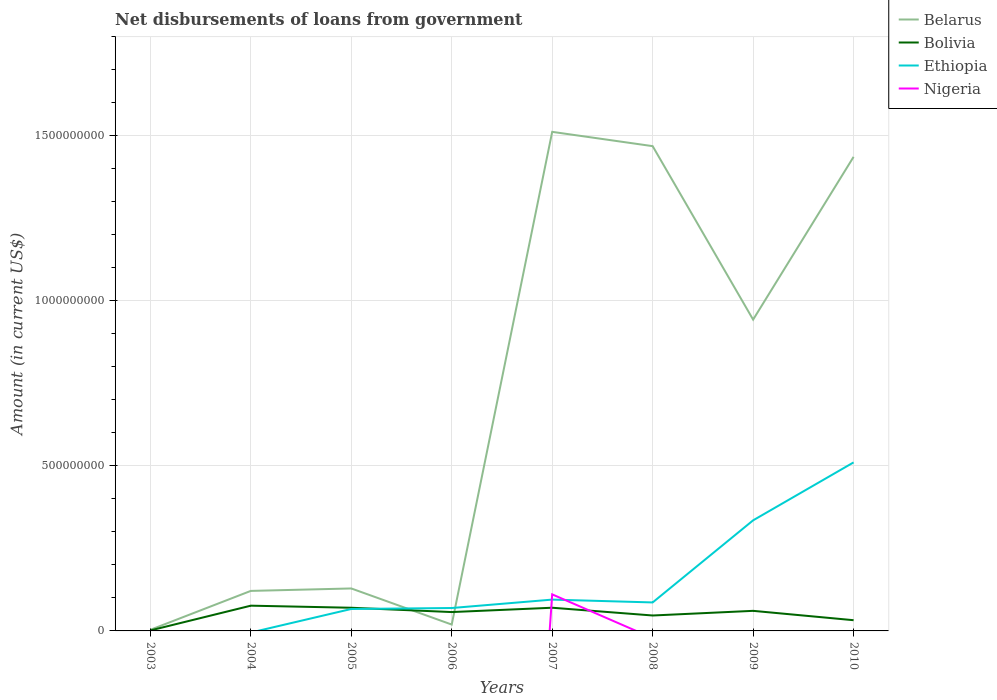Is the number of lines equal to the number of legend labels?
Provide a short and direct response. No. Across all years, what is the maximum amount of loan disbursed from government in Belarus?
Offer a terse response. 3.37e+06. What is the total amount of loan disbursed from government in Bolivia in the graph?
Your answer should be very brief. -1.31e+07. What is the difference between the highest and the second highest amount of loan disbursed from government in Nigeria?
Make the answer very short. 1.11e+08. Is the amount of loan disbursed from government in Belarus strictly greater than the amount of loan disbursed from government in Bolivia over the years?
Keep it short and to the point. No. How many lines are there?
Your response must be concise. 4. How many years are there in the graph?
Ensure brevity in your answer.  8. What is the difference between two consecutive major ticks on the Y-axis?
Your response must be concise. 5.00e+08. Are the values on the major ticks of Y-axis written in scientific E-notation?
Ensure brevity in your answer.  No. Does the graph contain any zero values?
Offer a very short reply. Yes. Does the graph contain grids?
Ensure brevity in your answer.  Yes. How many legend labels are there?
Your response must be concise. 4. How are the legend labels stacked?
Your answer should be compact. Vertical. What is the title of the graph?
Your answer should be very brief. Net disbursements of loans from government. What is the Amount (in current US$) in Belarus in 2003?
Offer a very short reply. 3.37e+06. What is the Amount (in current US$) in Bolivia in 2003?
Offer a terse response. 1.46e+06. What is the Amount (in current US$) in Belarus in 2004?
Your answer should be very brief. 1.21e+08. What is the Amount (in current US$) in Bolivia in 2004?
Make the answer very short. 7.65e+07. What is the Amount (in current US$) in Belarus in 2005?
Provide a succinct answer. 1.29e+08. What is the Amount (in current US$) in Bolivia in 2005?
Give a very brief answer. 7.02e+07. What is the Amount (in current US$) of Ethiopia in 2005?
Give a very brief answer. 6.65e+07. What is the Amount (in current US$) of Nigeria in 2005?
Offer a terse response. 0. What is the Amount (in current US$) in Belarus in 2006?
Ensure brevity in your answer.  1.93e+07. What is the Amount (in current US$) in Bolivia in 2006?
Give a very brief answer. 5.72e+07. What is the Amount (in current US$) in Ethiopia in 2006?
Provide a short and direct response. 6.94e+07. What is the Amount (in current US$) in Nigeria in 2006?
Offer a terse response. 0. What is the Amount (in current US$) of Belarus in 2007?
Keep it short and to the point. 1.51e+09. What is the Amount (in current US$) of Bolivia in 2007?
Keep it short and to the point. 7.03e+07. What is the Amount (in current US$) of Ethiopia in 2007?
Your answer should be very brief. 9.49e+07. What is the Amount (in current US$) in Nigeria in 2007?
Provide a succinct answer. 1.11e+08. What is the Amount (in current US$) in Belarus in 2008?
Keep it short and to the point. 1.47e+09. What is the Amount (in current US$) in Bolivia in 2008?
Provide a succinct answer. 4.68e+07. What is the Amount (in current US$) in Ethiopia in 2008?
Ensure brevity in your answer.  8.63e+07. What is the Amount (in current US$) of Belarus in 2009?
Offer a very short reply. 9.43e+08. What is the Amount (in current US$) of Bolivia in 2009?
Ensure brevity in your answer.  6.08e+07. What is the Amount (in current US$) in Ethiopia in 2009?
Your answer should be very brief. 3.35e+08. What is the Amount (in current US$) of Belarus in 2010?
Ensure brevity in your answer.  1.44e+09. What is the Amount (in current US$) of Bolivia in 2010?
Ensure brevity in your answer.  3.25e+07. What is the Amount (in current US$) of Ethiopia in 2010?
Your response must be concise. 5.11e+08. Across all years, what is the maximum Amount (in current US$) of Belarus?
Give a very brief answer. 1.51e+09. Across all years, what is the maximum Amount (in current US$) of Bolivia?
Offer a very short reply. 7.65e+07. Across all years, what is the maximum Amount (in current US$) of Ethiopia?
Keep it short and to the point. 5.11e+08. Across all years, what is the maximum Amount (in current US$) in Nigeria?
Provide a succinct answer. 1.11e+08. Across all years, what is the minimum Amount (in current US$) of Belarus?
Your response must be concise. 3.37e+06. Across all years, what is the minimum Amount (in current US$) of Bolivia?
Provide a short and direct response. 1.46e+06. Across all years, what is the minimum Amount (in current US$) of Ethiopia?
Give a very brief answer. 0. What is the total Amount (in current US$) in Belarus in the graph?
Your response must be concise. 5.63e+09. What is the total Amount (in current US$) in Bolivia in the graph?
Your answer should be compact. 4.16e+08. What is the total Amount (in current US$) in Ethiopia in the graph?
Your answer should be compact. 1.16e+09. What is the total Amount (in current US$) of Nigeria in the graph?
Keep it short and to the point. 1.11e+08. What is the difference between the Amount (in current US$) in Belarus in 2003 and that in 2004?
Keep it short and to the point. -1.18e+08. What is the difference between the Amount (in current US$) of Bolivia in 2003 and that in 2004?
Your answer should be compact. -7.50e+07. What is the difference between the Amount (in current US$) in Belarus in 2003 and that in 2005?
Provide a short and direct response. -1.25e+08. What is the difference between the Amount (in current US$) of Bolivia in 2003 and that in 2005?
Ensure brevity in your answer.  -6.88e+07. What is the difference between the Amount (in current US$) in Belarus in 2003 and that in 2006?
Ensure brevity in your answer.  -1.59e+07. What is the difference between the Amount (in current US$) of Bolivia in 2003 and that in 2006?
Keep it short and to the point. -5.57e+07. What is the difference between the Amount (in current US$) in Belarus in 2003 and that in 2007?
Offer a terse response. -1.51e+09. What is the difference between the Amount (in current US$) of Bolivia in 2003 and that in 2007?
Give a very brief answer. -6.88e+07. What is the difference between the Amount (in current US$) of Belarus in 2003 and that in 2008?
Provide a succinct answer. -1.47e+09. What is the difference between the Amount (in current US$) in Bolivia in 2003 and that in 2008?
Offer a very short reply. -4.53e+07. What is the difference between the Amount (in current US$) in Belarus in 2003 and that in 2009?
Make the answer very short. -9.40e+08. What is the difference between the Amount (in current US$) in Bolivia in 2003 and that in 2009?
Your answer should be compact. -5.94e+07. What is the difference between the Amount (in current US$) in Belarus in 2003 and that in 2010?
Keep it short and to the point. -1.43e+09. What is the difference between the Amount (in current US$) of Bolivia in 2003 and that in 2010?
Your answer should be very brief. -3.10e+07. What is the difference between the Amount (in current US$) of Belarus in 2004 and that in 2005?
Your response must be concise. -7.44e+06. What is the difference between the Amount (in current US$) in Bolivia in 2004 and that in 2005?
Your answer should be very brief. 6.26e+06. What is the difference between the Amount (in current US$) in Belarus in 2004 and that in 2006?
Keep it short and to the point. 1.02e+08. What is the difference between the Amount (in current US$) in Bolivia in 2004 and that in 2006?
Provide a succinct answer. 1.93e+07. What is the difference between the Amount (in current US$) of Belarus in 2004 and that in 2007?
Make the answer very short. -1.39e+09. What is the difference between the Amount (in current US$) of Bolivia in 2004 and that in 2007?
Offer a terse response. 6.22e+06. What is the difference between the Amount (in current US$) of Belarus in 2004 and that in 2008?
Offer a terse response. -1.35e+09. What is the difference between the Amount (in current US$) of Bolivia in 2004 and that in 2008?
Make the answer very short. 2.97e+07. What is the difference between the Amount (in current US$) of Belarus in 2004 and that in 2009?
Give a very brief answer. -8.22e+08. What is the difference between the Amount (in current US$) of Bolivia in 2004 and that in 2009?
Ensure brevity in your answer.  1.57e+07. What is the difference between the Amount (in current US$) in Belarus in 2004 and that in 2010?
Your answer should be compact. -1.32e+09. What is the difference between the Amount (in current US$) of Bolivia in 2004 and that in 2010?
Your answer should be very brief. 4.40e+07. What is the difference between the Amount (in current US$) in Belarus in 2005 and that in 2006?
Offer a very short reply. 1.09e+08. What is the difference between the Amount (in current US$) in Bolivia in 2005 and that in 2006?
Make the answer very short. 1.31e+07. What is the difference between the Amount (in current US$) of Ethiopia in 2005 and that in 2006?
Provide a short and direct response. -2.93e+06. What is the difference between the Amount (in current US$) of Belarus in 2005 and that in 2007?
Give a very brief answer. -1.38e+09. What is the difference between the Amount (in current US$) in Bolivia in 2005 and that in 2007?
Make the answer very short. -4.80e+04. What is the difference between the Amount (in current US$) of Ethiopia in 2005 and that in 2007?
Ensure brevity in your answer.  -2.84e+07. What is the difference between the Amount (in current US$) of Belarus in 2005 and that in 2008?
Your response must be concise. -1.34e+09. What is the difference between the Amount (in current US$) in Bolivia in 2005 and that in 2008?
Provide a short and direct response. 2.35e+07. What is the difference between the Amount (in current US$) of Ethiopia in 2005 and that in 2008?
Provide a succinct answer. -1.98e+07. What is the difference between the Amount (in current US$) in Belarus in 2005 and that in 2009?
Your response must be concise. -8.15e+08. What is the difference between the Amount (in current US$) in Bolivia in 2005 and that in 2009?
Provide a succinct answer. 9.39e+06. What is the difference between the Amount (in current US$) of Ethiopia in 2005 and that in 2009?
Provide a short and direct response. -2.69e+08. What is the difference between the Amount (in current US$) in Belarus in 2005 and that in 2010?
Your answer should be very brief. -1.31e+09. What is the difference between the Amount (in current US$) in Bolivia in 2005 and that in 2010?
Your response must be concise. 3.77e+07. What is the difference between the Amount (in current US$) of Ethiopia in 2005 and that in 2010?
Your answer should be compact. -4.44e+08. What is the difference between the Amount (in current US$) of Belarus in 2006 and that in 2007?
Give a very brief answer. -1.49e+09. What is the difference between the Amount (in current US$) of Bolivia in 2006 and that in 2007?
Make the answer very short. -1.31e+07. What is the difference between the Amount (in current US$) in Ethiopia in 2006 and that in 2007?
Make the answer very short. -2.55e+07. What is the difference between the Amount (in current US$) of Belarus in 2006 and that in 2008?
Your answer should be very brief. -1.45e+09. What is the difference between the Amount (in current US$) in Bolivia in 2006 and that in 2008?
Provide a short and direct response. 1.04e+07. What is the difference between the Amount (in current US$) in Ethiopia in 2006 and that in 2008?
Offer a terse response. -1.69e+07. What is the difference between the Amount (in current US$) of Belarus in 2006 and that in 2009?
Make the answer very short. -9.24e+08. What is the difference between the Amount (in current US$) of Bolivia in 2006 and that in 2009?
Keep it short and to the point. -3.67e+06. What is the difference between the Amount (in current US$) in Ethiopia in 2006 and that in 2009?
Your answer should be compact. -2.66e+08. What is the difference between the Amount (in current US$) in Belarus in 2006 and that in 2010?
Offer a very short reply. -1.42e+09. What is the difference between the Amount (in current US$) in Bolivia in 2006 and that in 2010?
Give a very brief answer. 2.47e+07. What is the difference between the Amount (in current US$) in Ethiopia in 2006 and that in 2010?
Ensure brevity in your answer.  -4.41e+08. What is the difference between the Amount (in current US$) in Belarus in 2007 and that in 2008?
Ensure brevity in your answer.  4.33e+07. What is the difference between the Amount (in current US$) of Bolivia in 2007 and that in 2008?
Keep it short and to the point. 2.35e+07. What is the difference between the Amount (in current US$) of Ethiopia in 2007 and that in 2008?
Your answer should be compact. 8.58e+06. What is the difference between the Amount (in current US$) of Belarus in 2007 and that in 2009?
Provide a succinct answer. 5.69e+08. What is the difference between the Amount (in current US$) of Bolivia in 2007 and that in 2009?
Your answer should be very brief. 9.44e+06. What is the difference between the Amount (in current US$) in Ethiopia in 2007 and that in 2009?
Provide a short and direct response. -2.40e+08. What is the difference between the Amount (in current US$) in Belarus in 2007 and that in 2010?
Offer a very short reply. 7.57e+07. What is the difference between the Amount (in current US$) in Bolivia in 2007 and that in 2010?
Offer a very short reply. 3.78e+07. What is the difference between the Amount (in current US$) of Ethiopia in 2007 and that in 2010?
Provide a short and direct response. -4.16e+08. What is the difference between the Amount (in current US$) of Belarus in 2008 and that in 2009?
Your answer should be very brief. 5.26e+08. What is the difference between the Amount (in current US$) of Bolivia in 2008 and that in 2009?
Give a very brief answer. -1.41e+07. What is the difference between the Amount (in current US$) in Ethiopia in 2008 and that in 2009?
Offer a very short reply. -2.49e+08. What is the difference between the Amount (in current US$) in Belarus in 2008 and that in 2010?
Ensure brevity in your answer.  3.24e+07. What is the difference between the Amount (in current US$) in Bolivia in 2008 and that in 2010?
Provide a succinct answer. 1.43e+07. What is the difference between the Amount (in current US$) in Ethiopia in 2008 and that in 2010?
Make the answer very short. -4.24e+08. What is the difference between the Amount (in current US$) of Belarus in 2009 and that in 2010?
Your answer should be very brief. -4.93e+08. What is the difference between the Amount (in current US$) in Bolivia in 2009 and that in 2010?
Ensure brevity in your answer.  2.84e+07. What is the difference between the Amount (in current US$) of Ethiopia in 2009 and that in 2010?
Provide a succinct answer. -1.76e+08. What is the difference between the Amount (in current US$) of Belarus in 2003 and the Amount (in current US$) of Bolivia in 2004?
Your answer should be compact. -7.31e+07. What is the difference between the Amount (in current US$) in Belarus in 2003 and the Amount (in current US$) in Bolivia in 2005?
Your answer should be compact. -6.69e+07. What is the difference between the Amount (in current US$) of Belarus in 2003 and the Amount (in current US$) of Ethiopia in 2005?
Provide a short and direct response. -6.31e+07. What is the difference between the Amount (in current US$) in Bolivia in 2003 and the Amount (in current US$) in Ethiopia in 2005?
Provide a succinct answer. -6.50e+07. What is the difference between the Amount (in current US$) in Belarus in 2003 and the Amount (in current US$) in Bolivia in 2006?
Your answer should be very brief. -5.38e+07. What is the difference between the Amount (in current US$) in Belarus in 2003 and the Amount (in current US$) in Ethiopia in 2006?
Your response must be concise. -6.60e+07. What is the difference between the Amount (in current US$) of Bolivia in 2003 and the Amount (in current US$) of Ethiopia in 2006?
Provide a short and direct response. -6.80e+07. What is the difference between the Amount (in current US$) of Belarus in 2003 and the Amount (in current US$) of Bolivia in 2007?
Provide a short and direct response. -6.69e+07. What is the difference between the Amount (in current US$) in Belarus in 2003 and the Amount (in current US$) in Ethiopia in 2007?
Offer a very short reply. -9.15e+07. What is the difference between the Amount (in current US$) of Belarus in 2003 and the Amount (in current US$) of Nigeria in 2007?
Provide a succinct answer. -1.07e+08. What is the difference between the Amount (in current US$) of Bolivia in 2003 and the Amount (in current US$) of Ethiopia in 2007?
Ensure brevity in your answer.  -9.34e+07. What is the difference between the Amount (in current US$) in Bolivia in 2003 and the Amount (in current US$) in Nigeria in 2007?
Your answer should be very brief. -1.09e+08. What is the difference between the Amount (in current US$) of Belarus in 2003 and the Amount (in current US$) of Bolivia in 2008?
Give a very brief answer. -4.34e+07. What is the difference between the Amount (in current US$) in Belarus in 2003 and the Amount (in current US$) in Ethiopia in 2008?
Provide a short and direct response. -8.30e+07. What is the difference between the Amount (in current US$) of Bolivia in 2003 and the Amount (in current US$) of Ethiopia in 2008?
Offer a very short reply. -8.49e+07. What is the difference between the Amount (in current US$) of Belarus in 2003 and the Amount (in current US$) of Bolivia in 2009?
Your answer should be very brief. -5.75e+07. What is the difference between the Amount (in current US$) in Belarus in 2003 and the Amount (in current US$) in Ethiopia in 2009?
Your answer should be compact. -3.32e+08. What is the difference between the Amount (in current US$) in Bolivia in 2003 and the Amount (in current US$) in Ethiopia in 2009?
Offer a very short reply. -3.34e+08. What is the difference between the Amount (in current US$) in Belarus in 2003 and the Amount (in current US$) in Bolivia in 2010?
Your response must be concise. -2.91e+07. What is the difference between the Amount (in current US$) of Belarus in 2003 and the Amount (in current US$) of Ethiopia in 2010?
Your answer should be very brief. -5.07e+08. What is the difference between the Amount (in current US$) of Bolivia in 2003 and the Amount (in current US$) of Ethiopia in 2010?
Your response must be concise. -5.09e+08. What is the difference between the Amount (in current US$) in Belarus in 2004 and the Amount (in current US$) in Bolivia in 2005?
Provide a succinct answer. 5.10e+07. What is the difference between the Amount (in current US$) in Belarus in 2004 and the Amount (in current US$) in Ethiopia in 2005?
Your answer should be compact. 5.48e+07. What is the difference between the Amount (in current US$) in Bolivia in 2004 and the Amount (in current US$) in Ethiopia in 2005?
Offer a very short reply. 1.00e+07. What is the difference between the Amount (in current US$) in Belarus in 2004 and the Amount (in current US$) in Bolivia in 2006?
Provide a short and direct response. 6.41e+07. What is the difference between the Amount (in current US$) of Belarus in 2004 and the Amount (in current US$) of Ethiopia in 2006?
Make the answer very short. 5.18e+07. What is the difference between the Amount (in current US$) in Bolivia in 2004 and the Amount (in current US$) in Ethiopia in 2006?
Give a very brief answer. 7.08e+06. What is the difference between the Amount (in current US$) in Belarus in 2004 and the Amount (in current US$) in Bolivia in 2007?
Provide a succinct answer. 5.10e+07. What is the difference between the Amount (in current US$) of Belarus in 2004 and the Amount (in current US$) of Ethiopia in 2007?
Your answer should be very brief. 2.64e+07. What is the difference between the Amount (in current US$) in Belarus in 2004 and the Amount (in current US$) in Nigeria in 2007?
Provide a short and direct response. 1.05e+07. What is the difference between the Amount (in current US$) in Bolivia in 2004 and the Amount (in current US$) in Ethiopia in 2007?
Offer a terse response. -1.84e+07. What is the difference between the Amount (in current US$) of Bolivia in 2004 and the Amount (in current US$) of Nigeria in 2007?
Offer a terse response. -3.43e+07. What is the difference between the Amount (in current US$) in Belarus in 2004 and the Amount (in current US$) in Bolivia in 2008?
Make the answer very short. 7.45e+07. What is the difference between the Amount (in current US$) of Belarus in 2004 and the Amount (in current US$) of Ethiopia in 2008?
Your answer should be compact. 3.49e+07. What is the difference between the Amount (in current US$) in Bolivia in 2004 and the Amount (in current US$) in Ethiopia in 2008?
Your answer should be very brief. -9.83e+06. What is the difference between the Amount (in current US$) in Belarus in 2004 and the Amount (in current US$) in Bolivia in 2009?
Make the answer very short. 6.04e+07. What is the difference between the Amount (in current US$) in Belarus in 2004 and the Amount (in current US$) in Ethiopia in 2009?
Your response must be concise. -2.14e+08. What is the difference between the Amount (in current US$) of Bolivia in 2004 and the Amount (in current US$) of Ethiopia in 2009?
Provide a succinct answer. -2.59e+08. What is the difference between the Amount (in current US$) of Belarus in 2004 and the Amount (in current US$) of Bolivia in 2010?
Keep it short and to the point. 8.88e+07. What is the difference between the Amount (in current US$) in Belarus in 2004 and the Amount (in current US$) in Ethiopia in 2010?
Your answer should be very brief. -3.89e+08. What is the difference between the Amount (in current US$) in Bolivia in 2004 and the Amount (in current US$) in Ethiopia in 2010?
Give a very brief answer. -4.34e+08. What is the difference between the Amount (in current US$) of Belarus in 2005 and the Amount (in current US$) of Bolivia in 2006?
Give a very brief answer. 7.15e+07. What is the difference between the Amount (in current US$) of Belarus in 2005 and the Amount (in current US$) of Ethiopia in 2006?
Provide a short and direct response. 5.93e+07. What is the difference between the Amount (in current US$) in Bolivia in 2005 and the Amount (in current US$) in Ethiopia in 2006?
Provide a short and direct response. 8.10e+05. What is the difference between the Amount (in current US$) in Belarus in 2005 and the Amount (in current US$) in Bolivia in 2007?
Ensure brevity in your answer.  5.84e+07. What is the difference between the Amount (in current US$) of Belarus in 2005 and the Amount (in current US$) of Ethiopia in 2007?
Provide a succinct answer. 3.38e+07. What is the difference between the Amount (in current US$) of Belarus in 2005 and the Amount (in current US$) of Nigeria in 2007?
Your answer should be compact. 1.79e+07. What is the difference between the Amount (in current US$) in Bolivia in 2005 and the Amount (in current US$) in Ethiopia in 2007?
Ensure brevity in your answer.  -2.47e+07. What is the difference between the Amount (in current US$) of Bolivia in 2005 and the Amount (in current US$) of Nigeria in 2007?
Offer a very short reply. -4.06e+07. What is the difference between the Amount (in current US$) of Ethiopia in 2005 and the Amount (in current US$) of Nigeria in 2007?
Keep it short and to the point. -4.43e+07. What is the difference between the Amount (in current US$) in Belarus in 2005 and the Amount (in current US$) in Bolivia in 2008?
Give a very brief answer. 8.20e+07. What is the difference between the Amount (in current US$) of Belarus in 2005 and the Amount (in current US$) of Ethiopia in 2008?
Give a very brief answer. 4.24e+07. What is the difference between the Amount (in current US$) in Bolivia in 2005 and the Amount (in current US$) in Ethiopia in 2008?
Provide a short and direct response. -1.61e+07. What is the difference between the Amount (in current US$) of Belarus in 2005 and the Amount (in current US$) of Bolivia in 2009?
Your response must be concise. 6.79e+07. What is the difference between the Amount (in current US$) of Belarus in 2005 and the Amount (in current US$) of Ethiopia in 2009?
Keep it short and to the point. -2.06e+08. What is the difference between the Amount (in current US$) of Bolivia in 2005 and the Amount (in current US$) of Ethiopia in 2009?
Your response must be concise. -2.65e+08. What is the difference between the Amount (in current US$) of Belarus in 2005 and the Amount (in current US$) of Bolivia in 2010?
Ensure brevity in your answer.  9.62e+07. What is the difference between the Amount (in current US$) of Belarus in 2005 and the Amount (in current US$) of Ethiopia in 2010?
Offer a very short reply. -3.82e+08. What is the difference between the Amount (in current US$) of Bolivia in 2005 and the Amount (in current US$) of Ethiopia in 2010?
Offer a very short reply. -4.40e+08. What is the difference between the Amount (in current US$) of Belarus in 2006 and the Amount (in current US$) of Bolivia in 2007?
Give a very brief answer. -5.10e+07. What is the difference between the Amount (in current US$) in Belarus in 2006 and the Amount (in current US$) in Ethiopia in 2007?
Your answer should be very brief. -7.56e+07. What is the difference between the Amount (in current US$) in Belarus in 2006 and the Amount (in current US$) in Nigeria in 2007?
Give a very brief answer. -9.15e+07. What is the difference between the Amount (in current US$) in Bolivia in 2006 and the Amount (in current US$) in Ethiopia in 2007?
Ensure brevity in your answer.  -3.77e+07. What is the difference between the Amount (in current US$) of Bolivia in 2006 and the Amount (in current US$) of Nigeria in 2007?
Your answer should be very brief. -5.36e+07. What is the difference between the Amount (in current US$) in Ethiopia in 2006 and the Amount (in current US$) in Nigeria in 2007?
Provide a short and direct response. -4.14e+07. What is the difference between the Amount (in current US$) in Belarus in 2006 and the Amount (in current US$) in Bolivia in 2008?
Ensure brevity in your answer.  -2.75e+07. What is the difference between the Amount (in current US$) of Belarus in 2006 and the Amount (in current US$) of Ethiopia in 2008?
Ensure brevity in your answer.  -6.71e+07. What is the difference between the Amount (in current US$) of Bolivia in 2006 and the Amount (in current US$) of Ethiopia in 2008?
Your answer should be very brief. -2.92e+07. What is the difference between the Amount (in current US$) of Belarus in 2006 and the Amount (in current US$) of Bolivia in 2009?
Provide a succinct answer. -4.16e+07. What is the difference between the Amount (in current US$) in Belarus in 2006 and the Amount (in current US$) in Ethiopia in 2009?
Provide a short and direct response. -3.16e+08. What is the difference between the Amount (in current US$) of Bolivia in 2006 and the Amount (in current US$) of Ethiopia in 2009?
Offer a terse response. -2.78e+08. What is the difference between the Amount (in current US$) of Belarus in 2006 and the Amount (in current US$) of Bolivia in 2010?
Offer a terse response. -1.32e+07. What is the difference between the Amount (in current US$) of Belarus in 2006 and the Amount (in current US$) of Ethiopia in 2010?
Your response must be concise. -4.91e+08. What is the difference between the Amount (in current US$) in Bolivia in 2006 and the Amount (in current US$) in Ethiopia in 2010?
Provide a short and direct response. -4.54e+08. What is the difference between the Amount (in current US$) of Belarus in 2007 and the Amount (in current US$) of Bolivia in 2008?
Make the answer very short. 1.47e+09. What is the difference between the Amount (in current US$) of Belarus in 2007 and the Amount (in current US$) of Ethiopia in 2008?
Ensure brevity in your answer.  1.43e+09. What is the difference between the Amount (in current US$) of Bolivia in 2007 and the Amount (in current US$) of Ethiopia in 2008?
Keep it short and to the point. -1.60e+07. What is the difference between the Amount (in current US$) of Belarus in 2007 and the Amount (in current US$) of Bolivia in 2009?
Ensure brevity in your answer.  1.45e+09. What is the difference between the Amount (in current US$) in Belarus in 2007 and the Amount (in current US$) in Ethiopia in 2009?
Provide a succinct answer. 1.18e+09. What is the difference between the Amount (in current US$) in Bolivia in 2007 and the Amount (in current US$) in Ethiopia in 2009?
Provide a succinct answer. -2.65e+08. What is the difference between the Amount (in current US$) in Belarus in 2007 and the Amount (in current US$) in Bolivia in 2010?
Provide a succinct answer. 1.48e+09. What is the difference between the Amount (in current US$) of Belarus in 2007 and the Amount (in current US$) of Ethiopia in 2010?
Keep it short and to the point. 1.00e+09. What is the difference between the Amount (in current US$) in Bolivia in 2007 and the Amount (in current US$) in Ethiopia in 2010?
Offer a terse response. -4.40e+08. What is the difference between the Amount (in current US$) in Belarus in 2008 and the Amount (in current US$) in Bolivia in 2009?
Your response must be concise. 1.41e+09. What is the difference between the Amount (in current US$) in Belarus in 2008 and the Amount (in current US$) in Ethiopia in 2009?
Give a very brief answer. 1.13e+09. What is the difference between the Amount (in current US$) of Bolivia in 2008 and the Amount (in current US$) of Ethiopia in 2009?
Offer a very short reply. -2.88e+08. What is the difference between the Amount (in current US$) of Belarus in 2008 and the Amount (in current US$) of Bolivia in 2010?
Your answer should be very brief. 1.44e+09. What is the difference between the Amount (in current US$) of Belarus in 2008 and the Amount (in current US$) of Ethiopia in 2010?
Offer a very short reply. 9.58e+08. What is the difference between the Amount (in current US$) of Bolivia in 2008 and the Amount (in current US$) of Ethiopia in 2010?
Ensure brevity in your answer.  -4.64e+08. What is the difference between the Amount (in current US$) of Belarus in 2009 and the Amount (in current US$) of Bolivia in 2010?
Your answer should be compact. 9.11e+08. What is the difference between the Amount (in current US$) of Belarus in 2009 and the Amount (in current US$) of Ethiopia in 2010?
Your response must be concise. 4.33e+08. What is the difference between the Amount (in current US$) in Bolivia in 2009 and the Amount (in current US$) in Ethiopia in 2010?
Keep it short and to the point. -4.50e+08. What is the average Amount (in current US$) of Belarus per year?
Your answer should be compact. 7.04e+08. What is the average Amount (in current US$) of Bolivia per year?
Your response must be concise. 5.20e+07. What is the average Amount (in current US$) of Ethiopia per year?
Ensure brevity in your answer.  1.45e+08. What is the average Amount (in current US$) in Nigeria per year?
Your answer should be compact. 1.38e+07. In the year 2003, what is the difference between the Amount (in current US$) of Belarus and Amount (in current US$) of Bolivia?
Ensure brevity in your answer.  1.92e+06. In the year 2004, what is the difference between the Amount (in current US$) in Belarus and Amount (in current US$) in Bolivia?
Provide a short and direct response. 4.48e+07. In the year 2005, what is the difference between the Amount (in current US$) in Belarus and Amount (in current US$) in Bolivia?
Provide a succinct answer. 5.85e+07. In the year 2005, what is the difference between the Amount (in current US$) in Belarus and Amount (in current US$) in Ethiopia?
Ensure brevity in your answer.  6.22e+07. In the year 2005, what is the difference between the Amount (in current US$) in Bolivia and Amount (in current US$) in Ethiopia?
Provide a short and direct response. 3.74e+06. In the year 2006, what is the difference between the Amount (in current US$) of Belarus and Amount (in current US$) of Bolivia?
Your answer should be very brief. -3.79e+07. In the year 2006, what is the difference between the Amount (in current US$) in Belarus and Amount (in current US$) in Ethiopia?
Your answer should be very brief. -5.01e+07. In the year 2006, what is the difference between the Amount (in current US$) of Bolivia and Amount (in current US$) of Ethiopia?
Provide a succinct answer. -1.23e+07. In the year 2007, what is the difference between the Amount (in current US$) of Belarus and Amount (in current US$) of Bolivia?
Offer a very short reply. 1.44e+09. In the year 2007, what is the difference between the Amount (in current US$) in Belarus and Amount (in current US$) in Ethiopia?
Keep it short and to the point. 1.42e+09. In the year 2007, what is the difference between the Amount (in current US$) in Belarus and Amount (in current US$) in Nigeria?
Your answer should be compact. 1.40e+09. In the year 2007, what is the difference between the Amount (in current US$) of Bolivia and Amount (in current US$) of Ethiopia?
Make the answer very short. -2.46e+07. In the year 2007, what is the difference between the Amount (in current US$) in Bolivia and Amount (in current US$) in Nigeria?
Provide a short and direct response. -4.05e+07. In the year 2007, what is the difference between the Amount (in current US$) in Ethiopia and Amount (in current US$) in Nigeria?
Offer a terse response. -1.59e+07. In the year 2008, what is the difference between the Amount (in current US$) of Belarus and Amount (in current US$) of Bolivia?
Offer a terse response. 1.42e+09. In the year 2008, what is the difference between the Amount (in current US$) in Belarus and Amount (in current US$) in Ethiopia?
Your answer should be very brief. 1.38e+09. In the year 2008, what is the difference between the Amount (in current US$) in Bolivia and Amount (in current US$) in Ethiopia?
Make the answer very short. -3.96e+07. In the year 2009, what is the difference between the Amount (in current US$) of Belarus and Amount (in current US$) of Bolivia?
Ensure brevity in your answer.  8.82e+08. In the year 2009, what is the difference between the Amount (in current US$) in Belarus and Amount (in current US$) in Ethiopia?
Your response must be concise. 6.08e+08. In the year 2009, what is the difference between the Amount (in current US$) in Bolivia and Amount (in current US$) in Ethiopia?
Offer a very short reply. -2.74e+08. In the year 2010, what is the difference between the Amount (in current US$) in Belarus and Amount (in current US$) in Bolivia?
Offer a very short reply. 1.40e+09. In the year 2010, what is the difference between the Amount (in current US$) of Belarus and Amount (in current US$) of Ethiopia?
Give a very brief answer. 9.26e+08. In the year 2010, what is the difference between the Amount (in current US$) of Bolivia and Amount (in current US$) of Ethiopia?
Ensure brevity in your answer.  -4.78e+08. What is the ratio of the Amount (in current US$) of Belarus in 2003 to that in 2004?
Make the answer very short. 0.03. What is the ratio of the Amount (in current US$) of Bolivia in 2003 to that in 2004?
Offer a very short reply. 0.02. What is the ratio of the Amount (in current US$) in Belarus in 2003 to that in 2005?
Make the answer very short. 0.03. What is the ratio of the Amount (in current US$) in Bolivia in 2003 to that in 2005?
Ensure brevity in your answer.  0.02. What is the ratio of the Amount (in current US$) in Belarus in 2003 to that in 2006?
Provide a short and direct response. 0.17. What is the ratio of the Amount (in current US$) in Bolivia in 2003 to that in 2006?
Offer a very short reply. 0.03. What is the ratio of the Amount (in current US$) of Belarus in 2003 to that in 2007?
Provide a succinct answer. 0. What is the ratio of the Amount (in current US$) of Bolivia in 2003 to that in 2007?
Offer a very short reply. 0.02. What is the ratio of the Amount (in current US$) of Belarus in 2003 to that in 2008?
Make the answer very short. 0. What is the ratio of the Amount (in current US$) in Bolivia in 2003 to that in 2008?
Ensure brevity in your answer.  0.03. What is the ratio of the Amount (in current US$) in Belarus in 2003 to that in 2009?
Provide a short and direct response. 0. What is the ratio of the Amount (in current US$) in Bolivia in 2003 to that in 2009?
Ensure brevity in your answer.  0.02. What is the ratio of the Amount (in current US$) in Belarus in 2003 to that in 2010?
Keep it short and to the point. 0. What is the ratio of the Amount (in current US$) of Bolivia in 2003 to that in 2010?
Your answer should be very brief. 0.04. What is the ratio of the Amount (in current US$) in Belarus in 2004 to that in 2005?
Offer a very short reply. 0.94. What is the ratio of the Amount (in current US$) in Bolivia in 2004 to that in 2005?
Keep it short and to the point. 1.09. What is the ratio of the Amount (in current US$) of Belarus in 2004 to that in 2006?
Provide a short and direct response. 6.29. What is the ratio of the Amount (in current US$) in Bolivia in 2004 to that in 2006?
Give a very brief answer. 1.34. What is the ratio of the Amount (in current US$) of Belarus in 2004 to that in 2007?
Keep it short and to the point. 0.08. What is the ratio of the Amount (in current US$) in Bolivia in 2004 to that in 2007?
Give a very brief answer. 1.09. What is the ratio of the Amount (in current US$) in Belarus in 2004 to that in 2008?
Ensure brevity in your answer.  0.08. What is the ratio of the Amount (in current US$) in Bolivia in 2004 to that in 2008?
Offer a terse response. 1.64. What is the ratio of the Amount (in current US$) of Belarus in 2004 to that in 2009?
Your response must be concise. 0.13. What is the ratio of the Amount (in current US$) in Bolivia in 2004 to that in 2009?
Give a very brief answer. 1.26. What is the ratio of the Amount (in current US$) of Belarus in 2004 to that in 2010?
Keep it short and to the point. 0.08. What is the ratio of the Amount (in current US$) of Bolivia in 2004 to that in 2010?
Provide a succinct answer. 2.35. What is the ratio of the Amount (in current US$) of Belarus in 2005 to that in 2006?
Provide a succinct answer. 6.68. What is the ratio of the Amount (in current US$) in Bolivia in 2005 to that in 2006?
Offer a terse response. 1.23. What is the ratio of the Amount (in current US$) in Ethiopia in 2005 to that in 2006?
Keep it short and to the point. 0.96. What is the ratio of the Amount (in current US$) in Belarus in 2005 to that in 2007?
Your answer should be compact. 0.09. What is the ratio of the Amount (in current US$) in Bolivia in 2005 to that in 2007?
Your answer should be very brief. 1. What is the ratio of the Amount (in current US$) in Ethiopia in 2005 to that in 2007?
Offer a terse response. 0.7. What is the ratio of the Amount (in current US$) of Belarus in 2005 to that in 2008?
Keep it short and to the point. 0.09. What is the ratio of the Amount (in current US$) in Bolivia in 2005 to that in 2008?
Provide a succinct answer. 1.5. What is the ratio of the Amount (in current US$) of Ethiopia in 2005 to that in 2008?
Provide a succinct answer. 0.77. What is the ratio of the Amount (in current US$) of Belarus in 2005 to that in 2009?
Provide a short and direct response. 0.14. What is the ratio of the Amount (in current US$) of Bolivia in 2005 to that in 2009?
Make the answer very short. 1.15. What is the ratio of the Amount (in current US$) of Ethiopia in 2005 to that in 2009?
Your response must be concise. 0.2. What is the ratio of the Amount (in current US$) of Belarus in 2005 to that in 2010?
Make the answer very short. 0.09. What is the ratio of the Amount (in current US$) in Bolivia in 2005 to that in 2010?
Keep it short and to the point. 2.16. What is the ratio of the Amount (in current US$) in Ethiopia in 2005 to that in 2010?
Make the answer very short. 0.13. What is the ratio of the Amount (in current US$) in Belarus in 2006 to that in 2007?
Provide a short and direct response. 0.01. What is the ratio of the Amount (in current US$) in Bolivia in 2006 to that in 2007?
Provide a succinct answer. 0.81. What is the ratio of the Amount (in current US$) in Ethiopia in 2006 to that in 2007?
Give a very brief answer. 0.73. What is the ratio of the Amount (in current US$) in Belarus in 2006 to that in 2008?
Provide a succinct answer. 0.01. What is the ratio of the Amount (in current US$) of Bolivia in 2006 to that in 2008?
Offer a very short reply. 1.22. What is the ratio of the Amount (in current US$) of Ethiopia in 2006 to that in 2008?
Your response must be concise. 0.8. What is the ratio of the Amount (in current US$) in Belarus in 2006 to that in 2009?
Your answer should be compact. 0.02. What is the ratio of the Amount (in current US$) in Bolivia in 2006 to that in 2009?
Provide a short and direct response. 0.94. What is the ratio of the Amount (in current US$) in Ethiopia in 2006 to that in 2009?
Provide a succinct answer. 0.21. What is the ratio of the Amount (in current US$) in Belarus in 2006 to that in 2010?
Ensure brevity in your answer.  0.01. What is the ratio of the Amount (in current US$) in Bolivia in 2006 to that in 2010?
Provide a succinct answer. 1.76. What is the ratio of the Amount (in current US$) in Ethiopia in 2006 to that in 2010?
Give a very brief answer. 0.14. What is the ratio of the Amount (in current US$) in Belarus in 2007 to that in 2008?
Give a very brief answer. 1.03. What is the ratio of the Amount (in current US$) in Bolivia in 2007 to that in 2008?
Make the answer very short. 1.5. What is the ratio of the Amount (in current US$) of Ethiopia in 2007 to that in 2008?
Your answer should be very brief. 1.1. What is the ratio of the Amount (in current US$) of Belarus in 2007 to that in 2009?
Offer a very short reply. 1.6. What is the ratio of the Amount (in current US$) of Bolivia in 2007 to that in 2009?
Give a very brief answer. 1.16. What is the ratio of the Amount (in current US$) of Ethiopia in 2007 to that in 2009?
Offer a terse response. 0.28. What is the ratio of the Amount (in current US$) in Belarus in 2007 to that in 2010?
Keep it short and to the point. 1.05. What is the ratio of the Amount (in current US$) in Bolivia in 2007 to that in 2010?
Ensure brevity in your answer.  2.16. What is the ratio of the Amount (in current US$) in Ethiopia in 2007 to that in 2010?
Your answer should be very brief. 0.19. What is the ratio of the Amount (in current US$) in Belarus in 2008 to that in 2009?
Provide a short and direct response. 1.56. What is the ratio of the Amount (in current US$) in Bolivia in 2008 to that in 2009?
Provide a short and direct response. 0.77. What is the ratio of the Amount (in current US$) in Ethiopia in 2008 to that in 2009?
Provide a short and direct response. 0.26. What is the ratio of the Amount (in current US$) of Belarus in 2008 to that in 2010?
Offer a very short reply. 1.02. What is the ratio of the Amount (in current US$) in Bolivia in 2008 to that in 2010?
Your answer should be compact. 1.44. What is the ratio of the Amount (in current US$) in Ethiopia in 2008 to that in 2010?
Provide a short and direct response. 0.17. What is the ratio of the Amount (in current US$) of Belarus in 2009 to that in 2010?
Offer a very short reply. 0.66. What is the ratio of the Amount (in current US$) of Bolivia in 2009 to that in 2010?
Your response must be concise. 1.87. What is the ratio of the Amount (in current US$) of Ethiopia in 2009 to that in 2010?
Make the answer very short. 0.66. What is the difference between the highest and the second highest Amount (in current US$) in Belarus?
Provide a short and direct response. 4.33e+07. What is the difference between the highest and the second highest Amount (in current US$) of Bolivia?
Your answer should be very brief. 6.22e+06. What is the difference between the highest and the second highest Amount (in current US$) of Ethiopia?
Ensure brevity in your answer.  1.76e+08. What is the difference between the highest and the lowest Amount (in current US$) of Belarus?
Offer a terse response. 1.51e+09. What is the difference between the highest and the lowest Amount (in current US$) in Bolivia?
Give a very brief answer. 7.50e+07. What is the difference between the highest and the lowest Amount (in current US$) in Ethiopia?
Ensure brevity in your answer.  5.11e+08. What is the difference between the highest and the lowest Amount (in current US$) in Nigeria?
Provide a succinct answer. 1.11e+08. 